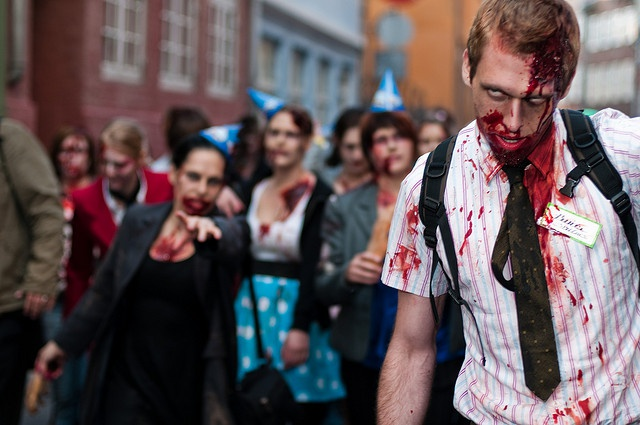Describe the objects in this image and their specific colors. I can see people in darkgreen, lightgray, black, darkgray, and brown tones, people in darkgreen, black, brown, maroon, and lightpink tones, people in darkgreen, black, blue, gray, and teal tones, people in darkgreen, black, gray, brown, and blue tones, and people in darkgreen, black, and gray tones in this image. 